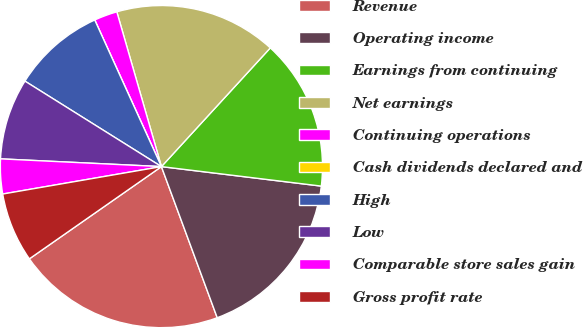Convert chart. <chart><loc_0><loc_0><loc_500><loc_500><pie_chart><fcel>Revenue<fcel>Operating income<fcel>Earnings from continuing<fcel>Net earnings<fcel>Continuing operations<fcel>Cash dividends declared and<fcel>High<fcel>Low<fcel>Comparable store sales gain<fcel>Gross profit rate<nl><fcel>20.93%<fcel>17.44%<fcel>15.12%<fcel>16.28%<fcel>2.33%<fcel>0.0%<fcel>9.3%<fcel>8.14%<fcel>3.49%<fcel>6.98%<nl></chart> 